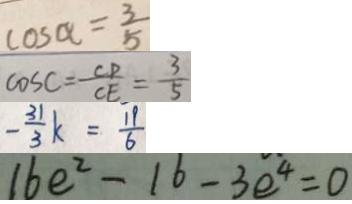<formula> <loc_0><loc_0><loc_500><loc_500>\cos \alpha = \frac { 3 } { 5 } 
 \cos C = \frac { C P } { C E } = \frac { 3 } { 5 } 
 - \frac { 3 1 } { 3 } k = \frac { 1 9 } { 6 } 
 1 6 e ^ { 2 } - 1 6 - 3 e ^ { 4 } = 0</formula> 